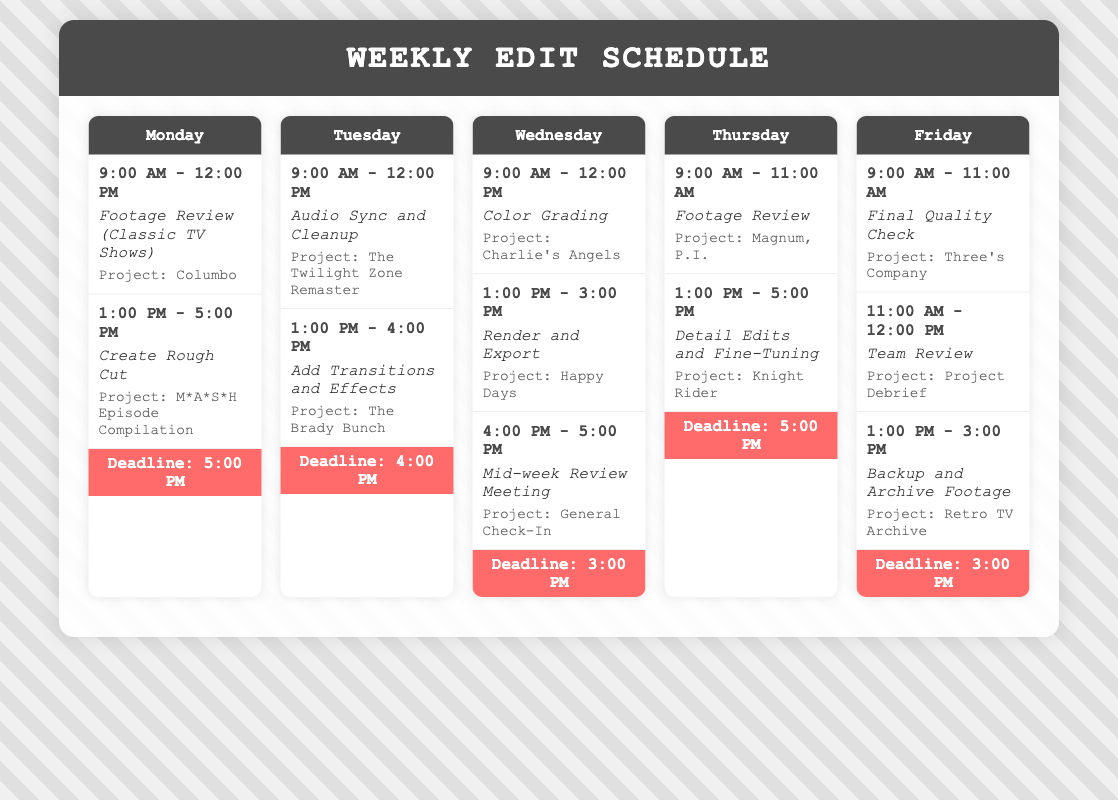what task is scheduled for Monday afternoon? The document lists "Create Rough Cut" as the task scheduled for Monday afternoon.
Answer: Create Rough Cut what is the project associated with the task "Audio Sync and Cleanup"? The project linked to the task "Audio Sync and Cleanup" is specified in the document.
Answer: The Twilight Zone Remaster how many hours are allocated for color grading on Wednesday? Color grading is scheduled for three hours on Wednesday, from 9:00 AM to 12:00 PM.
Answer: 3 hours what is the deadline for the projects on Thursday? The document states that the deadline for Thursday is at 5:00 PM.
Answer: 5:00 PM which project has a deadline on Wednesday? The document highlights that there is a deadline associated with tasks on Wednesday.
Answer: Happy Days what is the first task listed for Friday? The first task mentioned for Friday focuses on quality assurance.
Answer: Final Quality Check which day has a mid-week review meeting scheduled? The document indicates that there is a mid-week review meeting on Wednesday afternoon.
Answer: Wednesday how much time is allocated for backup and archiving footage on Friday? The document specifies that backup and archiving footage takes place for two hours on Friday afternoon.
Answer: 2 hours 